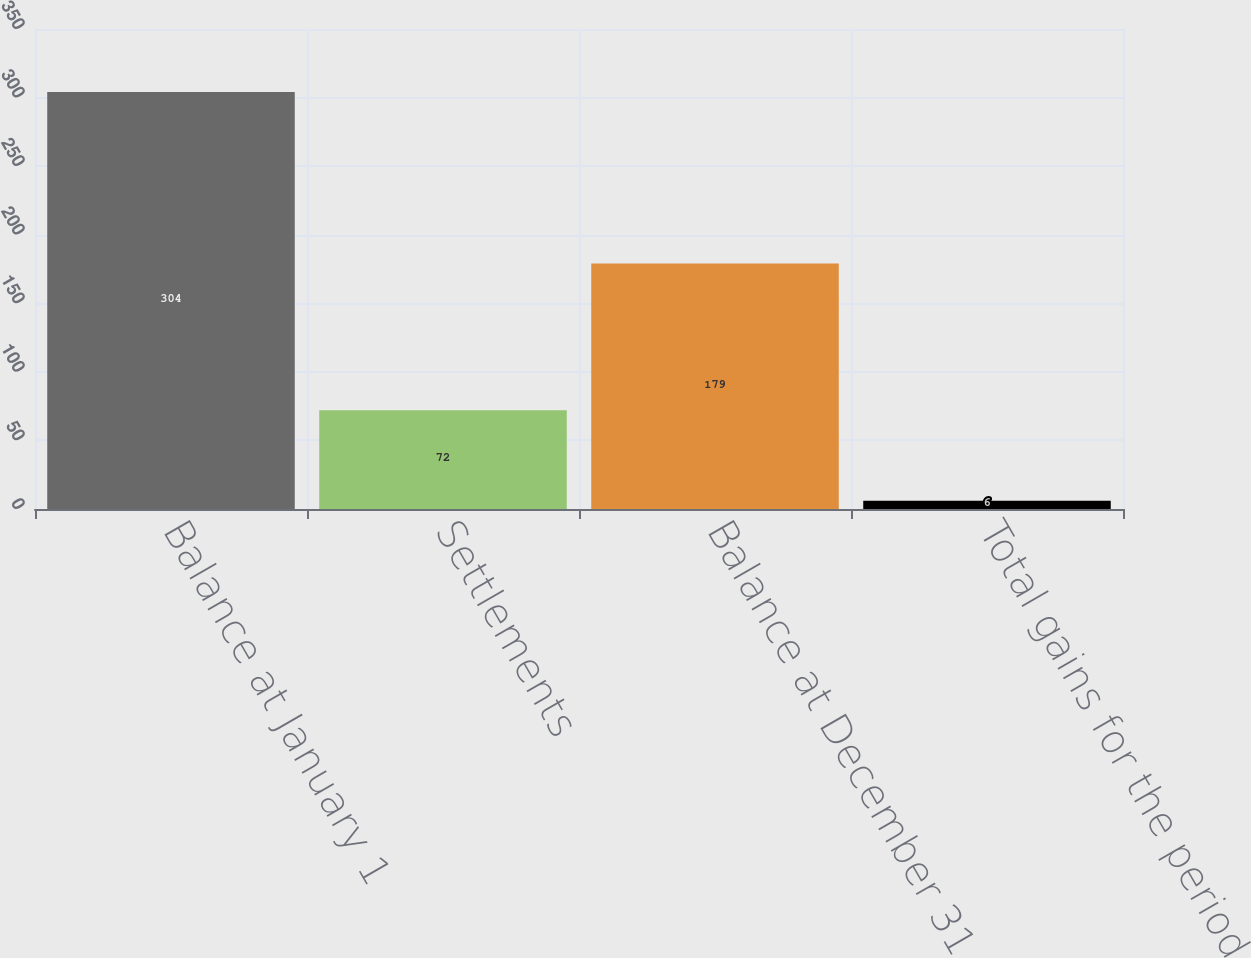<chart> <loc_0><loc_0><loc_500><loc_500><bar_chart><fcel>Balance at January 1<fcel>Settlements<fcel>Balance at December 31<fcel>Total gains for the period<nl><fcel>304<fcel>72<fcel>179<fcel>6<nl></chart> 